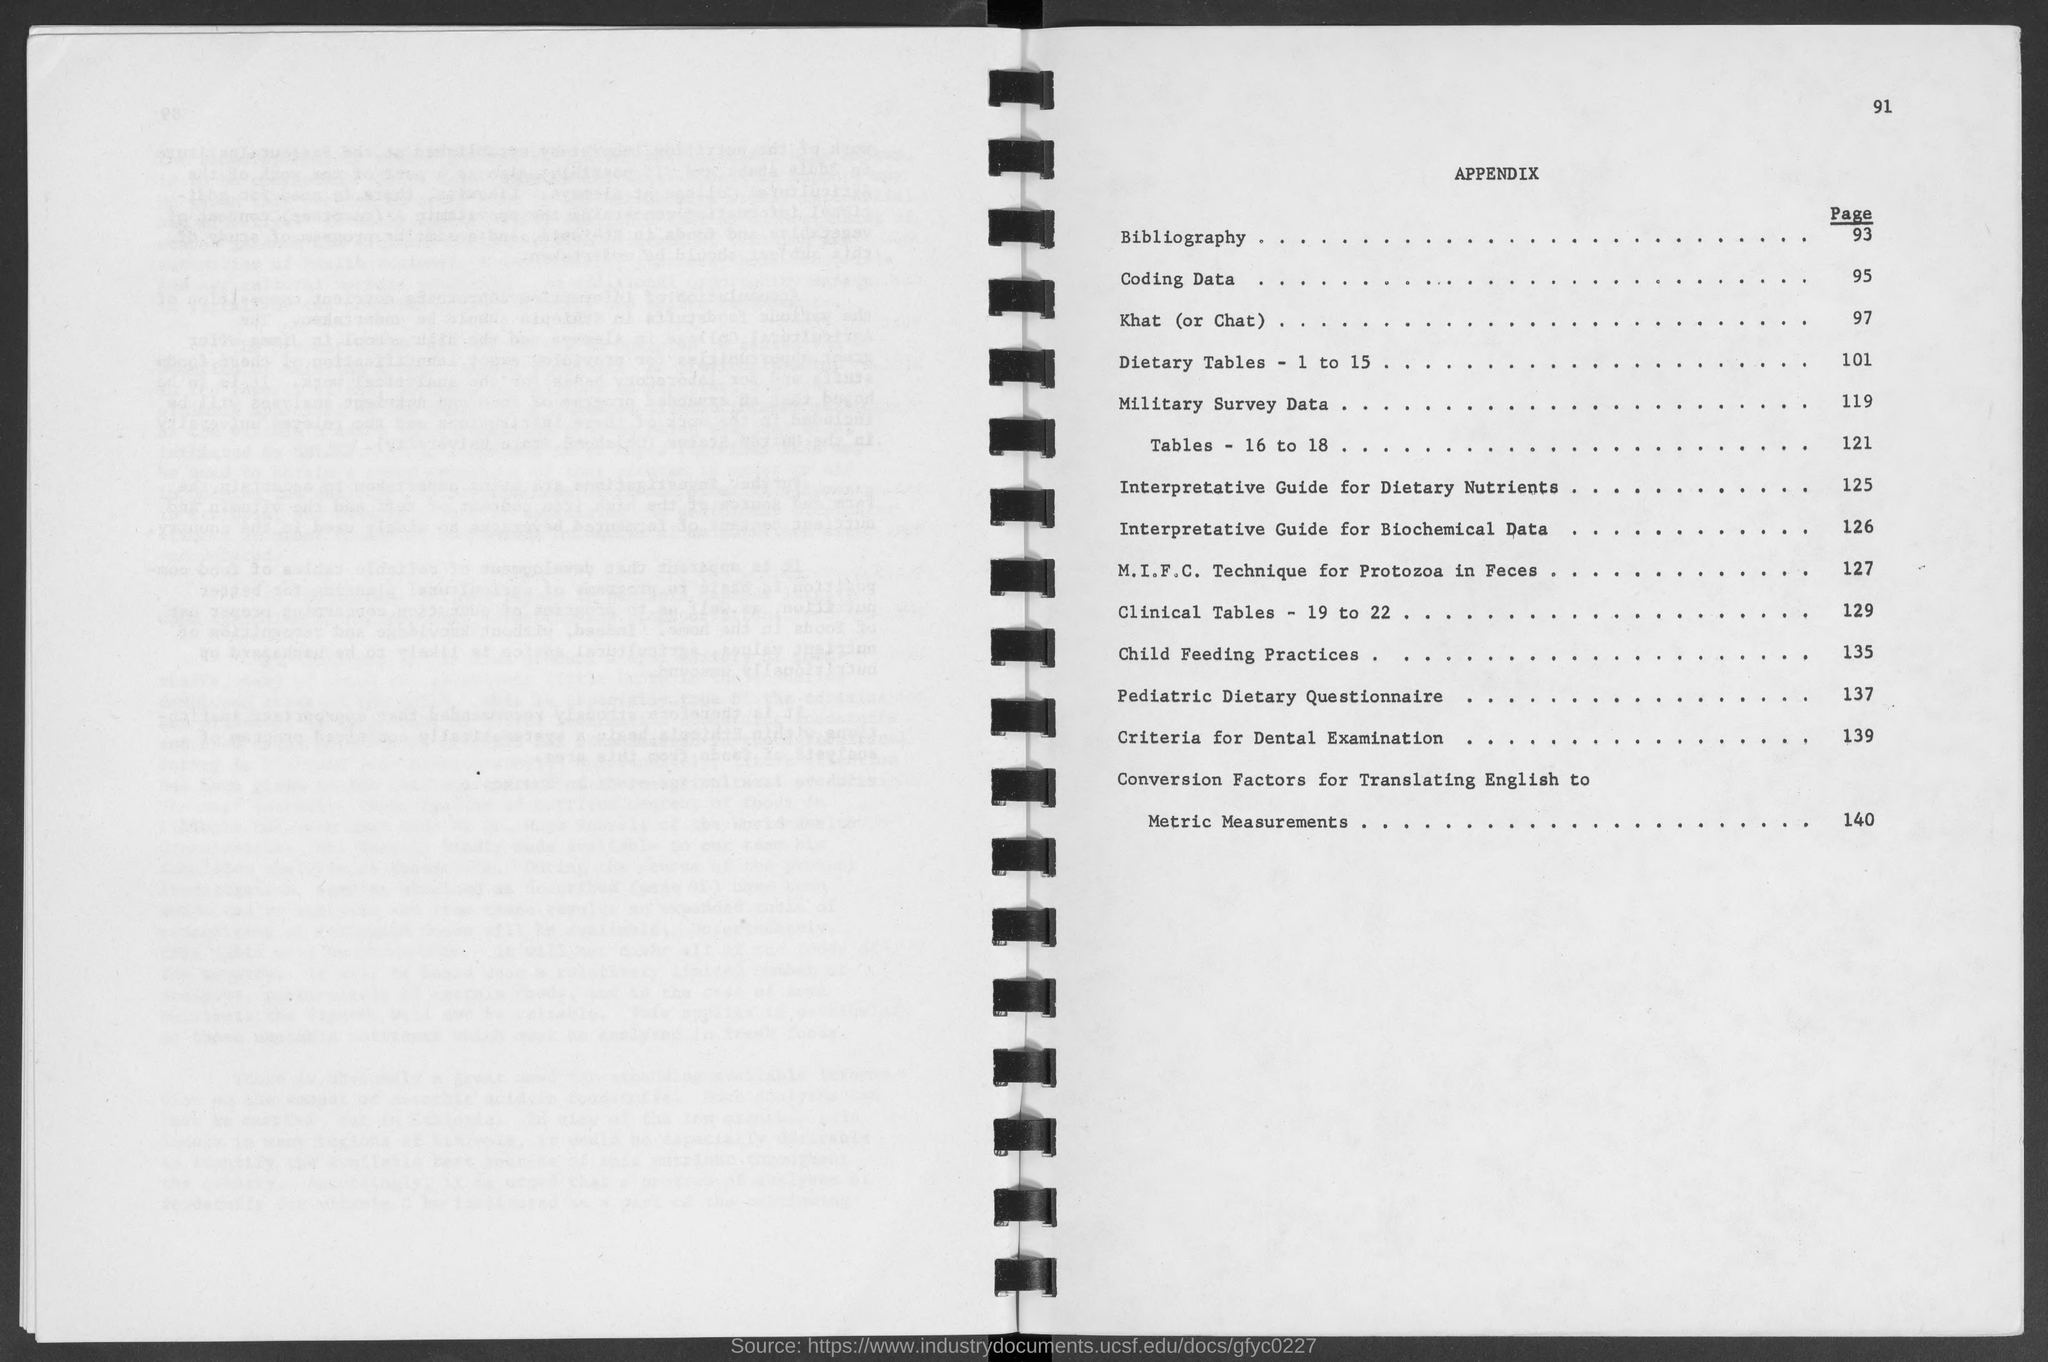Outline some significant characteristics in this image. The heading of the page is Appendix. The page number of "Conversion Factors for Translating English to Metric measurements" is 140. The page number of 'Coding data' is 95. The page number of "Criteria for Dental Examination" is 139. The number at the top-right corner of the page is 91. 